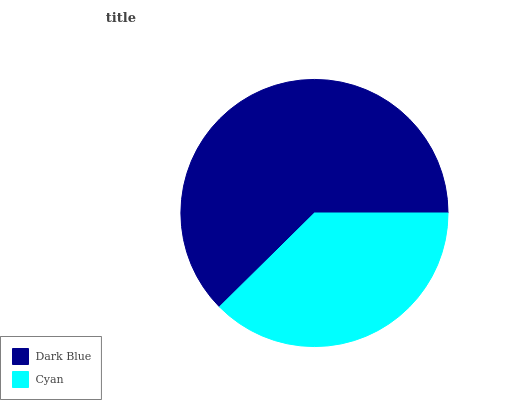Is Cyan the minimum?
Answer yes or no. Yes. Is Dark Blue the maximum?
Answer yes or no. Yes. Is Cyan the maximum?
Answer yes or no. No. Is Dark Blue greater than Cyan?
Answer yes or no. Yes. Is Cyan less than Dark Blue?
Answer yes or no. Yes. Is Cyan greater than Dark Blue?
Answer yes or no. No. Is Dark Blue less than Cyan?
Answer yes or no. No. Is Dark Blue the high median?
Answer yes or no. Yes. Is Cyan the low median?
Answer yes or no. Yes. Is Cyan the high median?
Answer yes or no. No. Is Dark Blue the low median?
Answer yes or no. No. 